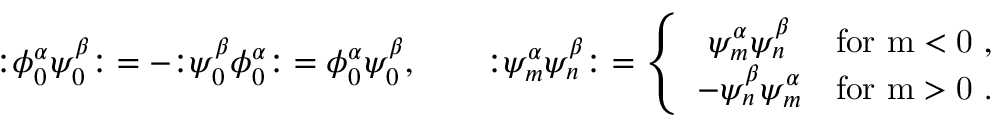Convert formula to latex. <formula><loc_0><loc_0><loc_500><loc_500>\mathopen \colon \phi _ { 0 } ^ { \alpha } \psi _ { 0 } ^ { \beta } \mathclose \colon = - \mathopen \colon \psi _ { 0 } ^ { \beta } \phi _ { 0 } ^ { \alpha } \mathclose \colon = \phi _ { 0 } ^ { \alpha } \psi _ { 0 } ^ { \beta } , \quad \mathopen \colon \psi _ { m } ^ { \alpha } \psi _ { n } ^ { \beta } \mathclose \colon = \left \{ \begin{array} { c l } { { \psi _ { m } ^ { \alpha } \psi _ { n } ^ { \beta } } } & { f o r m < 0 , } \\ { { - \psi _ { n } ^ { \beta } \psi _ { m } ^ { \alpha } } } & { f o r m > 0 . } \end{array}</formula> 